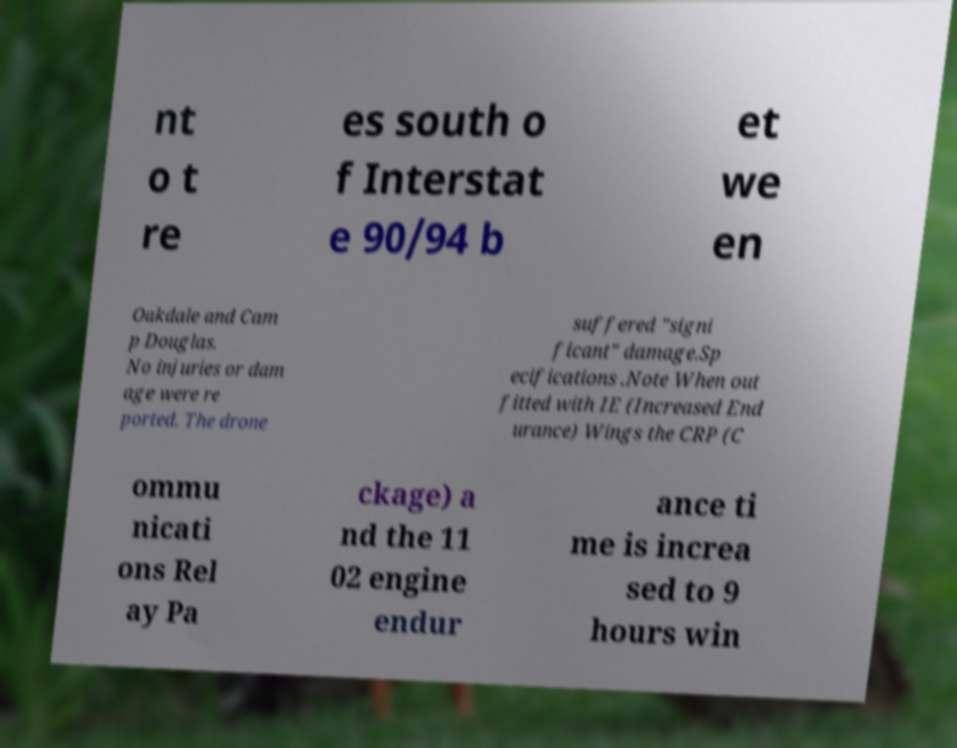Could you assist in decoding the text presented in this image and type it out clearly? nt o t re es south o f Interstat e 90/94 b et we en Oakdale and Cam p Douglas. No injuries or dam age were re ported. The drone suffered "signi ficant" damage.Sp ecifications .Note When out fitted with IE (Increased End urance) Wings the CRP (C ommu nicati ons Rel ay Pa ckage) a nd the 11 02 engine endur ance ti me is increa sed to 9 hours win 